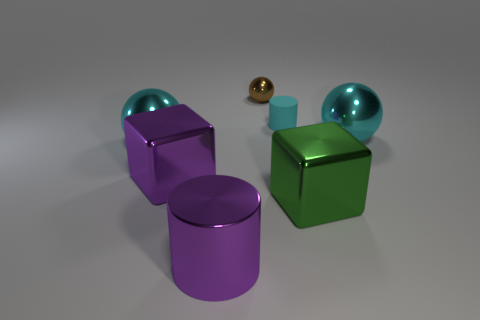Are there any other things that are the same material as the small cyan thing?
Give a very brief answer. No. Is the number of gray rubber things greater than the number of rubber cylinders?
Offer a terse response. No. What number of other things are there of the same shape as the green shiny thing?
Offer a very short reply. 1. Do the metal cylinder and the rubber object have the same color?
Your answer should be very brief. No. There is a big thing that is behind the large purple cube and on the left side of the purple cylinder; what material is it?
Your answer should be very brief. Metal. The brown sphere has what size?
Give a very brief answer. Small. How many purple cylinders are behind the cyan metal sphere that is behind the cyan shiny thing that is left of the small ball?
Give a very brief answer. 0. There is a purple shiny object in front of the green metallic thing on the right side of the small brown metal object; what is its shape?
Offer a terse response. Cylinder. There is a purple metal thing that is the same shape as the green metal object; what is its size?
Give a very brief answer. Large. Are there any other things that have the same size as the purple block?
Your response must be concise. Yes. 